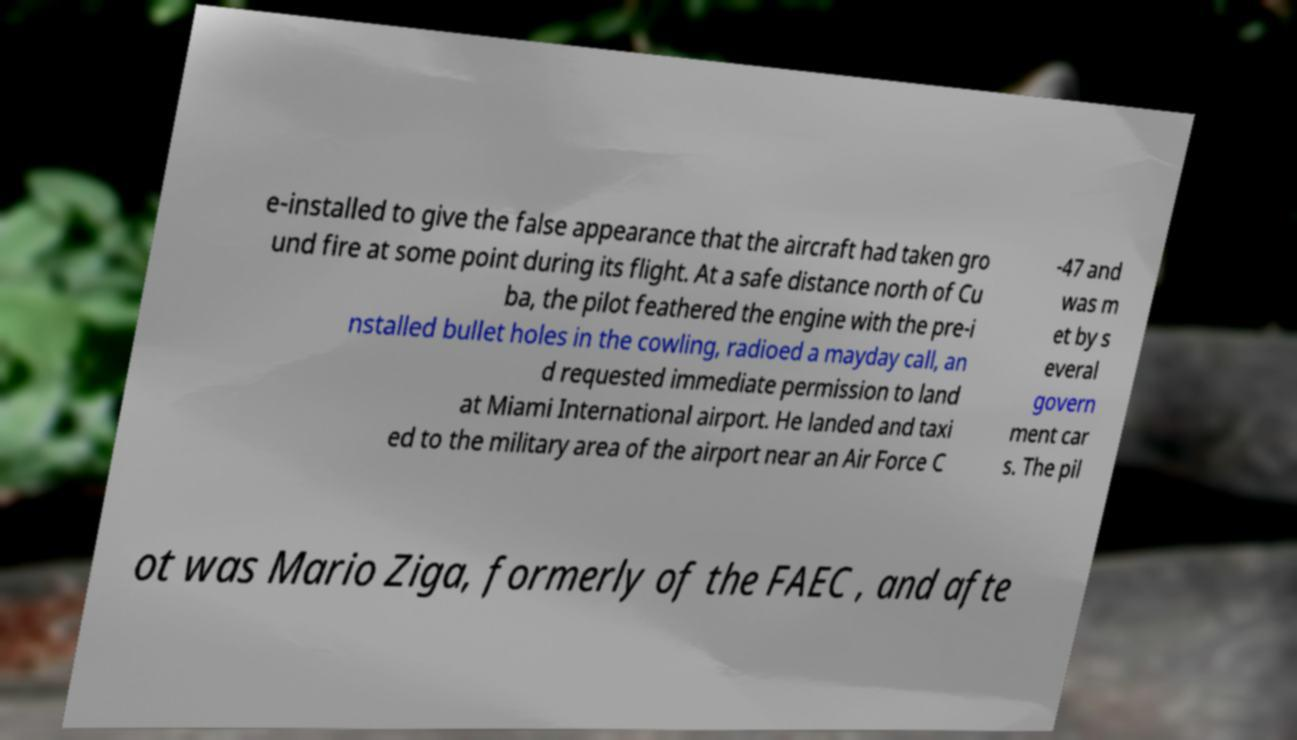There's text embedded in this image that I need extracted. Can you transcribe it verbatim? e-installed to give the false appearance that the aircraft had taken gro und fire at some point during its flight. At a safe distance north of Cu ba, the pilot feathered the engine with the pre-i nstalled bullet holes in the cowling, radioed a mayday call, an d requested immediate permission to land at Miami International airport. He landed and taxi ed to the military area of the airport near an Air Force C -47 and was m et by s everal govern ment car s. The pil ot was Mario Ziga, formerly of the FAEC , and afte 